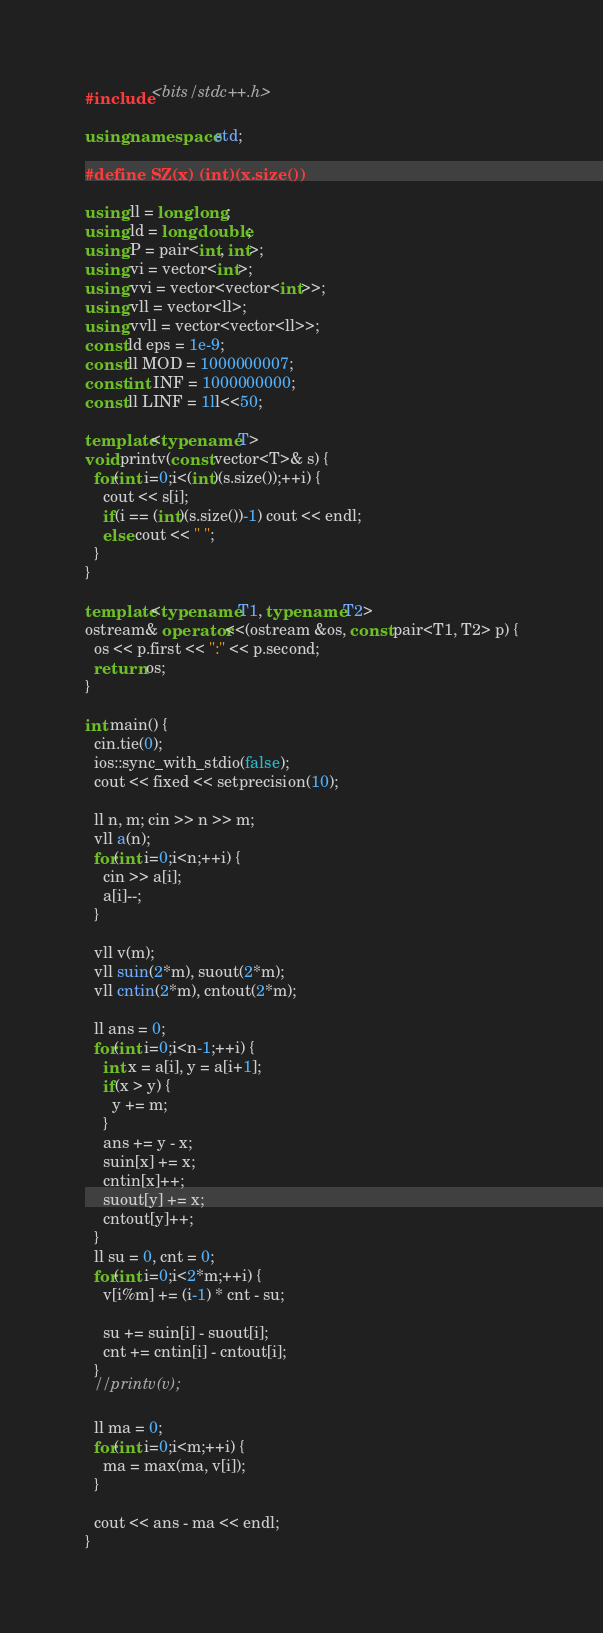<code> <loc_0><loc_0><loc_500><loc_500><_C++_>#include <bits/stdc++.h>

using namespace std;

#define SZ(x) (int)(x.size())

using ll = long long;
using ld = long double;
using P = pair<int, int>;
using vi = vector<int>;
using vvi = vector<vector<int>>;
using vll = vector<ll>;
using vvll = vector<vector<ll>>;
const ld eps = 1e-9;
const ll MOD = 1000000007;
const int INF = 1000000000;
const ll LINF = 1ll<<50;

template<typename T>
void printv(const vector<T>& s) {
  for(int i=0;i<(int)(s.size());++i) {
    cout << s[i];
    if(i == (int)(s.size())-1) cout << endl;
    else cout << " ";
  }
}

template<typename T1, typename T2>
ostream& operator<<(ostream &os, const pair<T1, T2> p) {
  os << p.first << ":" << p.second;
  return os;
}

int main() {
  cin.tie(0);
  ios::sync_with_stdio(false);
  cout << fixed << setprecision(10);

  ll n, m; cin >> n >> m;
  vll a(n);
  for(int i=0;i<n;++i) {
    cin >> a[i];
    a[i]--;
  }

  vll v(m);
  vll suin(2*m), suout(2*m);
  vll cntin(2*m), cntout(2*m);

  ll ans = 0;
  for(int i=0;i<n-1;++i) {
    int x = a[i], y = a[i+1];
    if(x > y) {
      y += m;
    }
    ans += y - x;
    suin[x] += x;
    cntin[x]++;
    suout[y] += x;
    cntout[y]++;
  }
  ll su = 0, cnt = 0;
  for(int i=0;i<2*m;++i) {
    v[i%m] += (i-1) * cnt - su;

    su += suin[i] - suout[i];
    cnt += cntin[i] - cntout[i];
  }
  //printv(v);

  ll ma = 0;
  for(int i=0;i<m;++i) {
    ma = max(ma, v[i]);
  }

  cout << ans - ma << endl;
}
</code> 